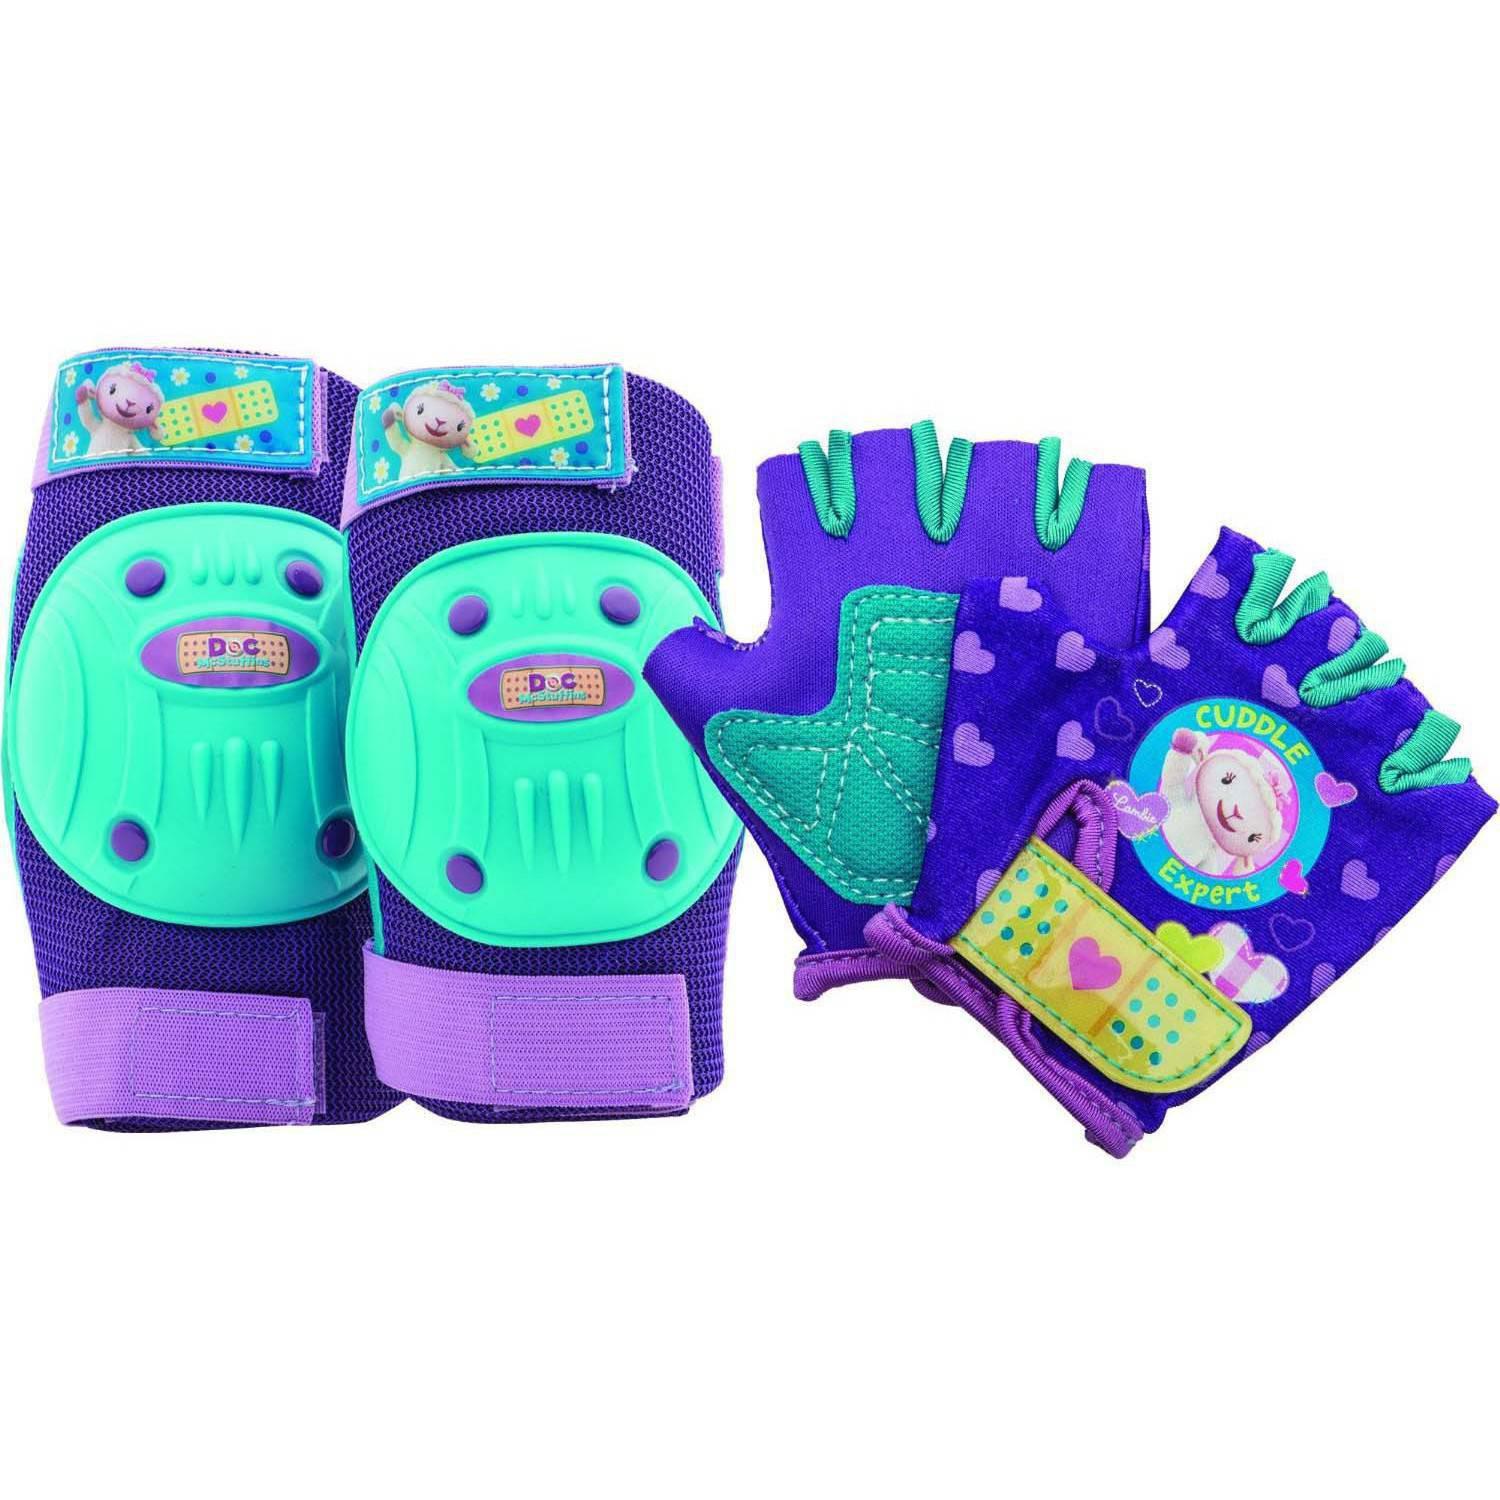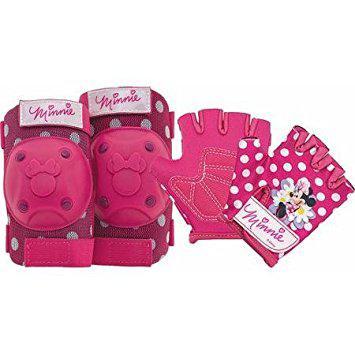The first image is the image on the left, the second image is the image on the right. Examine the images to the left and right. Is the description "One image contains exactly two roller skates and two pads." accurate? Answer yes or no. No. The first image is the image on the left, the second image is the image on the right. Analyze the images presented: Is the assertion "All images have both knee pads and gloves." valid? Answer yes or no. Yes. 